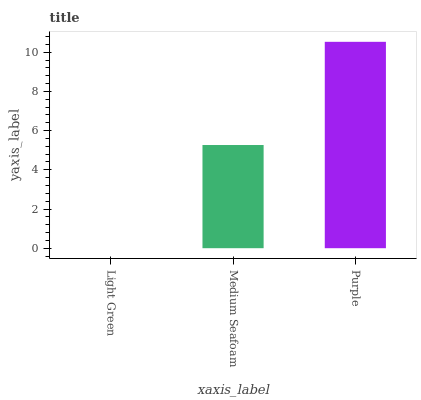Is Light Green the minimum?
Answer yes or no. Yes. Is Purple the maximum?
Answer yes or no. Yes. Is Medium Seafoam the minimum?
Answer yes or no. No. Is Medium Seafoam the maximum?
Answer yes or no. No. Is Medium Seafoam greater than Light Green?
Answer yes or no. Yes. Is Light Green less than Medium Seafoam?
Answer yes or no. Yes. Is Light Green greater than Medium Seafoam?
Answer yes or no. No. Is Medium Seafoam less than Light Green?
Answer yes or no. No. Is Medium Seafoam the high median?
Answer yes or no. Yes. Is Medium Seafoam the low median?
Answer yes or no. Yes. Is Purple the high median?
Answer yes or no. No. Is Light Green the low median?
Answer yes or no. No. 